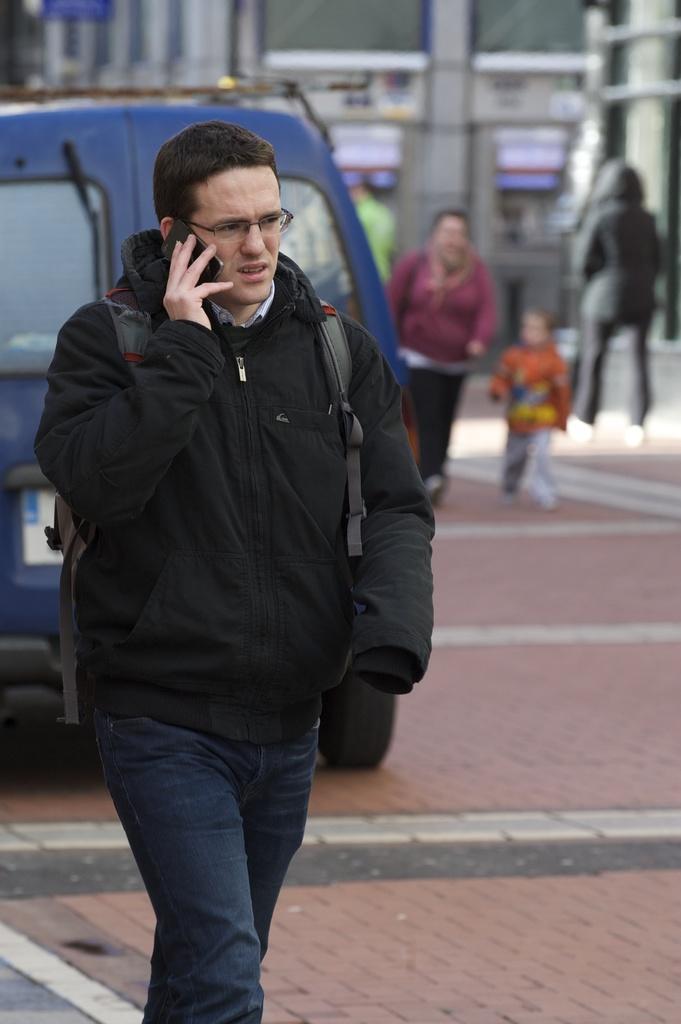In one or two sentences, can you explain what this image depicts? In this image we can see a person wearing specs and bag. He is talking on a phone. In the background there are vehicles. Also there are few vehicles. And there are few people. In the background it is blur. 